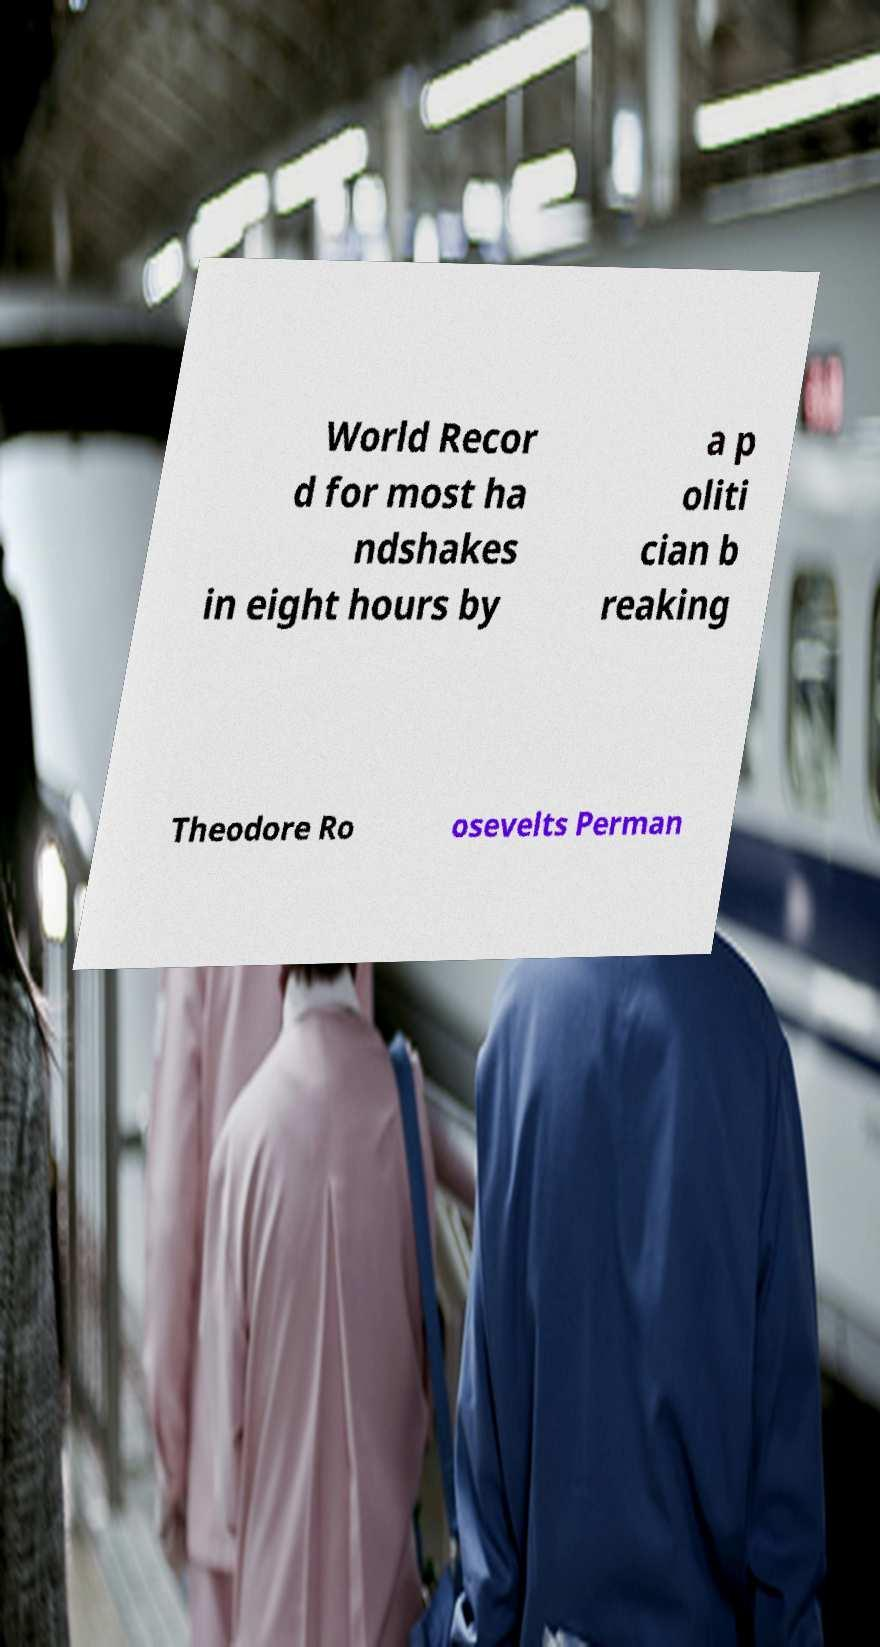I need the written content from this picture converted into text. Can you do that? World Recor d for most ha ndshakes in eight hours by a p oliti cian b reaking Theodore Ro osevelts Perman 